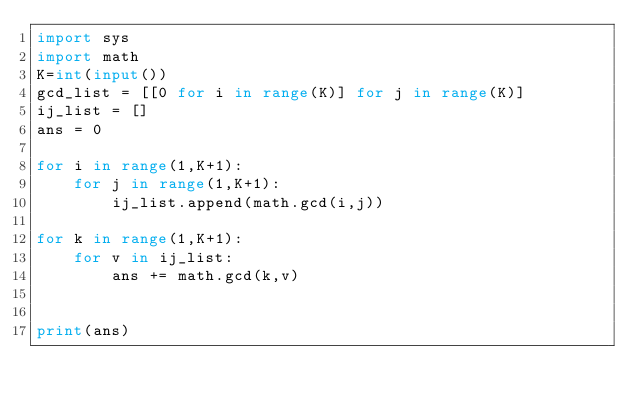Convert code to text. <code><loc_0><loc_0><loc_500><loc_500><_Python_>import sys
import math
K=int(input())
gcd_list = [[0 for i in range(K)] for j in range(K)]
ij_list = []
ans = 0

for i in range(1,K+1):
    for j in range(1,K+1):
        ij_list.append(math.gcd(i,j))

for k in range(1,K+1):
    for v in ij_list:
        ans += math.gcd(k,v)


print(ans)</code> 